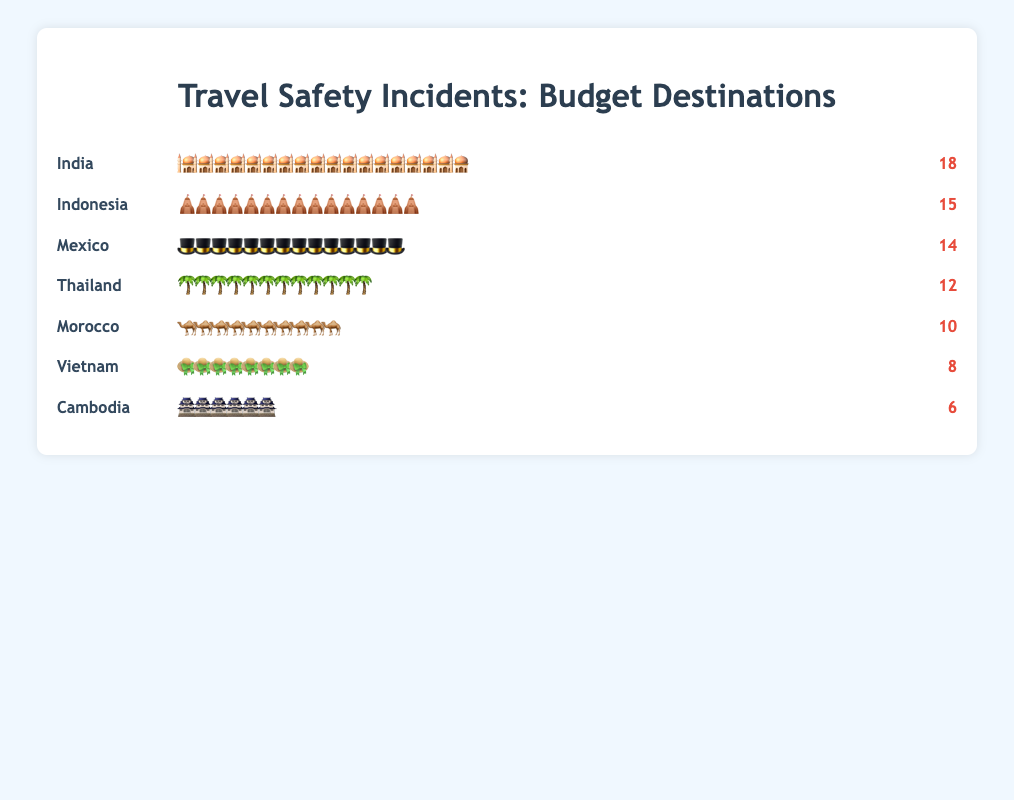Which destination had the highest number of travel safety incidents? Examine the icons next to each destination and the incident counts provided in the figure.
Answer: India Which destination had the lowest number of travel safety incidents? Look at the destination with the smallest number of icons and the smallest incident count.
Answer: Cambodia What is the total number of travel safety incidents across all destinations? Sum the incident counts for all destinations (12+8+15+6+18+10+14).
Answer: 83 How many more incidents occurred in India compared to Cambodia? Subtract the number of incidents in Cambodia from the number in India (18 - 6).
Answer: 12 Which destinations had more incidents than Thailand? Identify destinations with incident counts greater than Thailand's (Indonesia, India, Mexico).
Answer: Indonesia, India, Mexico How many incidents occurred in Indonesia and Morocco combined? Add the incidents from Indonesia and Morocco (15 + 10).
Answer: 25 What is the average number of incidents per destination? Divide the total number of incidents by the number of destinations (83 / 7).
Answer: 11.86 Which destination had exactly 8 travel safety incidents? Find the destination with 8 icons representing the incidents.
Answer: Vietnam Is the number of incidents in Mexico closer to India or Thailand? Calculate the difference in incidents with India (18 - 14) and Thailand (14 - 12); compare absolute values.
Answer: Thailand How many destinations had 10 or more travel safety incidents? Count the destinations with incident counts of 10 or more (India, Indonesia, Mexico, Thailand, Morocco).
Answer: 5 